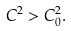Convert formula to latex. <formula><loc_0><loc_0><loc_500><loc_500>C ^ { 2 } > C _ { 0 } ^ { 2 } .</formula> 